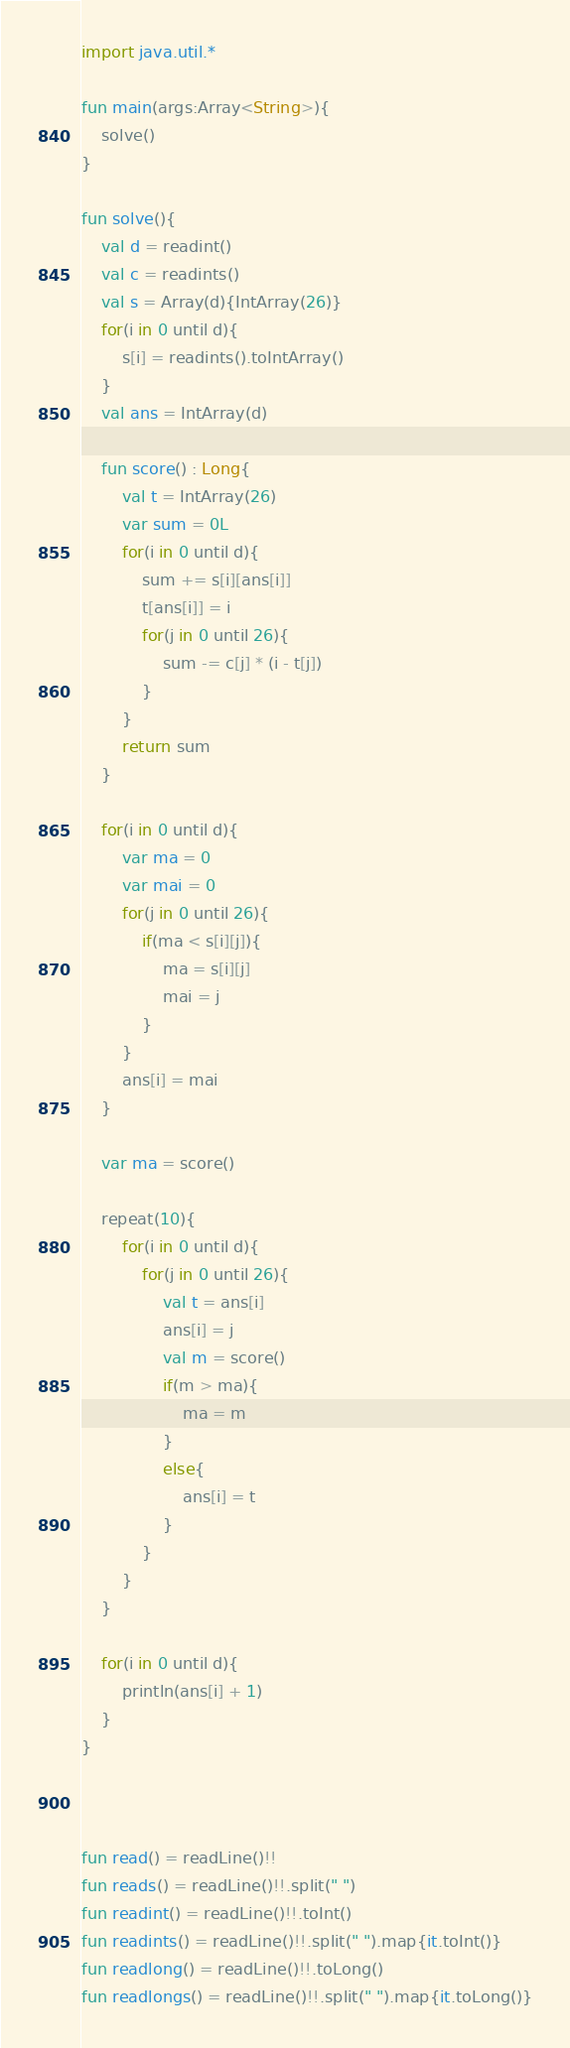<code> <loc_0><loc_0><loc_500><loc_500><_Kotlin_>import java.util.*

fun main(args:Array<String>){
    solve()
}

fun solve(){
    val d = readint()
    val c = readints()
    val s = Array(d){IntArray(26)}
    for(i in 0 until d){
        s[i] = readints().toIntArray()
    }
    val ans = IntArray(d)

    fun score() : Long{
        val t = IntArray(26)
        var sum = 0L
        for(i in 0 until d){
            sum += s[i][ans[i]]
            t[ans[i]] = i
            for(j in 0 until 26){
                sum -= c[j] * (i - t[j])
            }
        }
        return sum
    }

    for(i in 0 until d){
        var ma = 0
        var mai = 0
        for(j in 0 until 26){
            if(ma < s[i][j]){
                ma = s[i][j]
                mai = j
            }
        }
        ans[i] = mai
    }

    var ma = score()

    repeat(10){
        for(i in 0 until d){
            for(j in 0 until 26){
                val t = ans[i]
                ans[i] = j
                val m = score()
                if(m > ma){
                    ma = m
                }
                else{
                    ans[i] = t
                }
            }
        }
    }

    for(i in 0 until d){
        println(ans[i] + 1)
    }
}



fun read() = readLine()!!
fun reads() = readLine()!!.split(" ")
fun readint() = readLine()!!.toInt()
fun readints() = readLine()!!.split(" ").map{it.toInt()}
fun readlong() = readLine()!!.toLong()
fun readlongs() = readLine()!!.split(" ").map{it.toLong()}</code> 